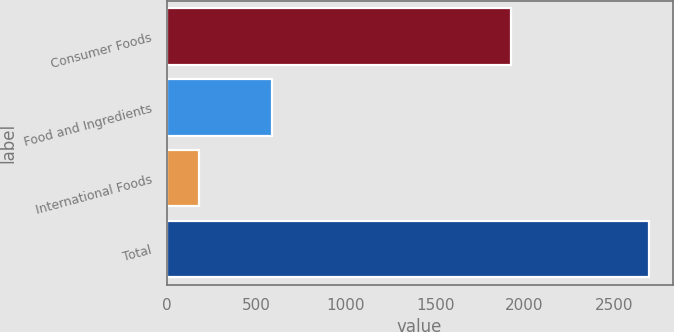Convert chart to OTSL. <chart><loc_0><loc_0><loc_500><loc_500><bar_chart><fcel>Consumer Foods<fcel>Food and Ingredients<fcel>International Foods<fcel>Total<nl><fcel>1923<fcel>590<fcel>180<fcel>2693<nl></chart> 